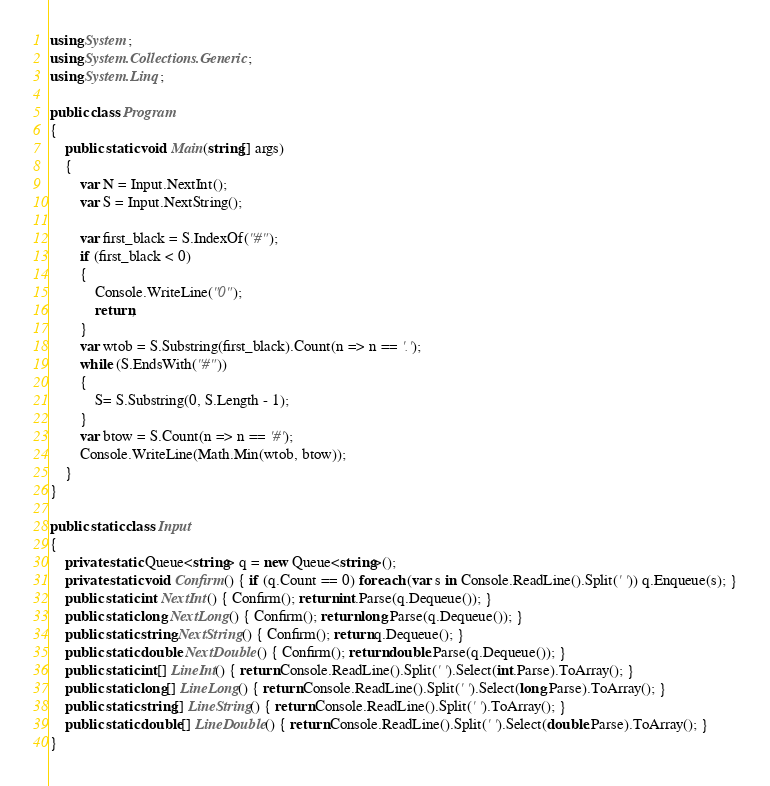<code> <loc_0><loc_0><loc_500><loc_500><_C#_>using System;
using System.Collections.Generic;
using System.Linq;

public class Program
{
    public static void Main(string[] args)
    {
        var N = Input.NextInt();
        var S = Input.NextString();

        var first_black = S.IndexOf("#");
        if (first_black < 0)
        {
            Console.WriteLine("0");
            return;
        }
        var wtob = S.Substring(first_black).Count(n => n == '.');
        while (S.EndsWith("#"))
        {
            S= S.Substring(0, S.Length - 1);
        }
        var btow = S.Count(n => n == '#');
        Console.WriteLine(Math.Min(wtob, btow));
    }
}

public static class Input
{
    private static Queue<string> q = new Queue<string>();
    private static void Confirm() { if (q.Count == 0) foreach (var s in Console.ReadLine().Split(' ')) q.Enqueue(s); }
    public static int NextInt() { Confirm(); return int.Parse(q.Dequeue()); }
    public static long NextLong() { Confirm(); return long.Parse(q.Dequeue()); }
    public static string NextString() { Confirm(); return q.Dequeue(); }
    public static double NextDouble() { Confirm(); return double.Parse(q.Dequeue()); }
    public static int[] LineInt() { return Console.ReadLine().Split(' ').Select(int.Parse).ToArray(); }
    public static long[] LineLong() { return Console.ReadLine().Split(' ').Select(long.Parse).ToArray(); }
    public static string[] LineString() { return Console.ReadLine().Split(' ').ToArray(); }
    public static double[] LineDouble() { return Console.ReadLine().Split(' ').Select(double.Parse).ToArray(); }
}

</code> 